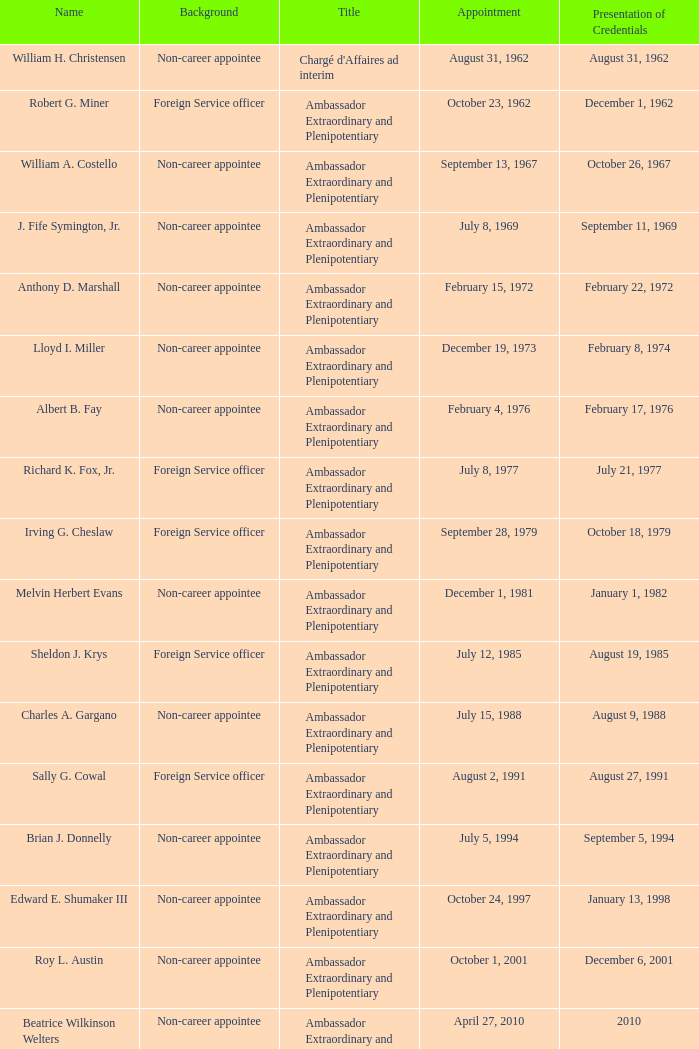What was the role of anthony d. marshall? Ambassador Extraordinary and Plenipotentiary. 